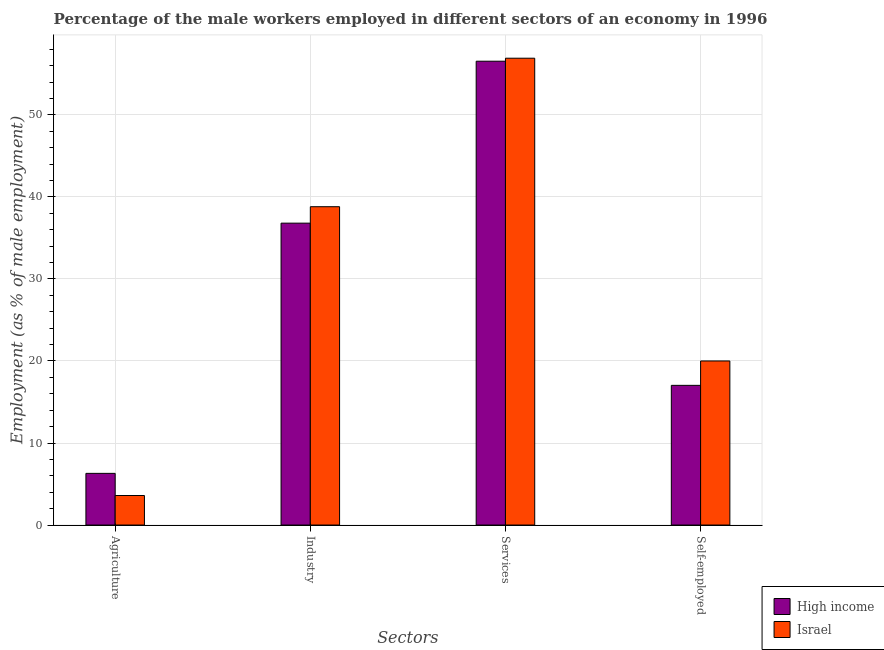How many different coloured bars are there?
Provide a short and direct response. 2. How many groups of bars are there?
Keep it short and to the point. 4. Are the number of bars on each tick of the X-axis equal?
Give a very brief answer. Yes. What is the label of the 4th group of bars from the left?
Ensure brevity in your answer.  Self-employed. What is the percentage of male workers in industry in Israel?
Make the answer very short. 38.8. Across all countries, what is the maximum percentage of male workers in industry?
Offer a terse response. 38.8. Across all countries, what is the minimum percentage of male workers in services?
Make the answer very short. 56.54. In which country was the percentage of male workers in industry minimum?
Keep it short and to the point. High income. What is the total percentage of self employed male workers in the graph?
Offer a very short reply. 37.03. What is the difference between the percentage of male workers in industry in Israel and that in High income?
Your answer should be compact. 2. What is the difference between the percentage of male workers in industry in High income and the percentage of male workers in services in Israel?
Your answer should be very brief. -20.1. What is the average percentage of male workers in agriculture per country?
Ensure brevity in your answer.  4.95. What is the difference between the percentage of male workers in agriculture and percentage of male workers in services in High income?
Offer a very short reply. -50.24. What is the ratio of the percentage of male workers in industry in High income to that in Israel?
Provide a succinct answer. 0.95. What is the difference between the highest and the second highest percentage of male workers in industry?
Provide a succinct answer. 2. What is the difference between the highest and the lowest percentage of male workers in services?
Your response must be concise. 0.36. Is it the case that in every country, the sum of the percentage of male workers in industry and percentage of male workers in services is greater than the sum of percentage of male workers in agriculture and percentage of self employed male workers?
Provide a succinct answer. Yes. What does the 2nd bar from the left in Agriculture represents?
Your response must be concise. Israel. What does the 1st bar from the right in Agriculture represents?
Give a very brief answer. Israel. Is it the case that in every country, the sum of the percentage of male workers in agriculture and percentage of male workers in industry is greater than the percentage of male workers in services?
Offer a terse response. No. How many bars are there?
Provide a succinct answer. 8. Are the values on the major ticks of Y-axis written in scientific E-notation?
Your answer should be compact. No. Does the graph contain grids?
Your response must be concise. Yes. How many legend labels are there?
Offer a terse response. 2. What is the title of the graph?
Offer a terse response. Percentage of the male workers employed in different sectors of an economy in 1996. What is the label or title of the X-axis?
Your response must be concise. Sectors. What is the label or title of the Y-axis?
Your answer should be very brief. Employment (as % of male employment). What is the Employment (as % of male employment) of High income in Agriculture?
Keep it short and to the point. 6.3. What is the Employment (as % of male employment) of Israel in Agriculture?
Make the answer very short. 3.6. What is the Employment (as % of male employment) in High income in Industry?
Your response must be concise. 36.8. What is the Employment (as % of male employment) of Israel in Industry?
Give a very brief answer. 38.8. What is the Employment (as % of male employment) of High income in Services?
Make the answer very short. 56.54. What is the Employment (as % of male employment) of Israel in Services?
Offer a very short reply. 56.9. What is the Employment (as % of male employment) in High income in Self-employed?
Offer a very short reply. 17.03. What is the Employment (as % of male employment) of Israel in Self-employed?
Provide a succinct answer. 20. Across all Sectors, what is the maximum Employment (as % of male employment) in High income?
Offer a very short reply. 56.54. Across all Sectors, what is the maximum Employment (as % of male employment) of Israel?
Give a very brief answer. 56.9. Across all Sectors, what is the minimum Employment (as % of male employment) of High income?
Offer a terse response. 6.3. Across all Sectors, what is the minimum Employment (as % of male employment) in Israel?
Offer a terse response. 3.6. What is the total Employment (as % of male employment) of High income in the graph?
Provide a short and direct response. 116.66. What is the total Employment (as % of male employment) of Israel in the graph?
Your response must be concise. 119.3. What is the difference between the Employment (as % of male employment) of High income in Agriculture and that in Industry?
Provide a short and direct response. -30.5. What is the difference between the Employment (as % of male employment) in Israel in Agriculture and that in Industry?
Ensure brevity in your answer.  -35.2. What is the difference between the Employment (as % of male employment) in High income in Agriculture and that in Services?
Make the answer very short. -50.24. What is the difference between the Employment (as % of male employment) of Israel in Agriculture and that in Services?
Your answer should be very brief. -53.3. What is the difference between the Employment (as % of male employment) in High income in Agriculture and that in Self-employed?
Give a very brief answer. -10.73. What is the difference between the Employment (as % of male employment) of Israel in Agriculture and that in Self-employed?
Offer a very short reply. -16.4. What is the difference between the Employment (as % of male employment) in High income in Industry and that in Services?
Provide a short and direct response. -19.74. What is the difference between the Employment (as % of male employment) in Israel in Industry and that in Services?
Provide a short and direct response. -18.1. What is the difference between the Employment (as % of male employment) in High income in Industry and that in Self-employed?
Your answer should be very brief. 19.77. What is the difference between the Employment (as % of male employment) of High income in Services and that in Self-employed?
Offer a terse response. 39.51. What is the difference between the Employment (as % of male employment) of Israel in Services and that in Self-employed?
Ensure brevity in your answer.  36.9. What is the difference between the Employment (as % of male employment) in High income in Agriculture and the Employment (as % of male employment) in Israel in Industry?
Offer a terse response. -32.5. What is the difference between the Employment (as % of male employment) in High income in Agriculture and the Employment (as % of male employment) in Israel in Services?
Provide a succinct answer. -50.6. What is the difference between the Employment (as % of male employment) in High income in Agriculture and the Employment (as % of male employment) in Israel in Self-employed?
Ensure brevity in your answer.  -13.7. What is the difference between the Employment (as % of male employment) of High income in Industry and the Employment (as % of male employment) of Israel in Services?
Offer a very short reply. -20.1. What is the difference between the Employment (as % of male employment) in High income in Industry and the Employment (as % of male employment) in Israel in Self-employed?
Offer a very short reply. 16.8. What is the difference between the Employment (as % of male employment) in High income in Services and the Employment (as % of male employment) in Israel in Self-employed?
Your answer should be compact. 36.54. What is the average Employment (as % of male employment) in High income per Sectors?
Keep it short and to the point. 29.16. What is the average Employment (as % of male employment) in Israel per Sectors?
Offer a terse response. 29.82. What is the difference between the Employment (as % of male employment) of High income and Employment (as % of male employment) of Israel in Agriculture?
Offer a terse response. 2.7. What is the difference between the Employment (as % of male employment) of High income and Employment (as % of male employment) of Israel in Industry?
Offer a very short reply. -2. What is the difference between the Employment (as % of male employment) of High income and Employment (as % of male employment) of Israel in Services?
Provide a succinct answer. -0.36. What is the difference between the Employment (as % of male employment) in High income and Employment (as % of male employment) in Israel in Self-employed?
Provide a succinct answer. -2.97. What is the ratio of the Employment (as % of male employment) of High income in Agriculture to that in Industry?
Provide a short and direct response. 0.17. What is the ratio of the Employment (as % of male employment) of Israel in Agriculture to that in Industry?
Your answer should be compact. 0.09. What is the ratio of the Employment (as % of male employment) in High income in Agriculture to that in Services?
Offer a terse response. 0.11. What is the ratio of the Employment (as % of male employment) in Israel in Agriculture to that in Services?
Make the answer very short. 0.06. What is the ratio of the Employment (as % of male employment) of High income in Agriculture to that in Self-employed?
Ensure brevity in your answer.  0.37. What is the ratio of the Employment (as % of male employment) of Israel in Agriculture to that in Self-employed?
Provide a succinct answer. 0.18. What is the ratio of the Employment (as % of male employment) of High income in Industry to that in Services?
Keep it short and to the point. 0.65. What is the ratio of the Employment (as % of male employment) of Israel in Industry to that in Services?
Make the answer very short. 0.68. What is the ratio of the Employment (as % of male employment) of High income in Industry to that in Self-employed?
Offer a terse response. 2.16. What is the ratio of the Employment (as % of male employment) of Israel in Industry to that in Self-employed?
Give a very brief answer. 1.94. What is the ratio of the Employment (as % of male employment) of High income in Services to that in Self-employed?
Provide a succinct answer. 3.32. What is the ratio of the Employment (as % of male employment) of Israel in Services to that in Self-employed?
Provide a succinct answer. 2.85. What is the difference between the highest and the second highest Employment (as % of male employment) in High income?
Your answer should be compact. 19.74. What is the difference between the highest and the second highest Employment (as % of male employment) in Israel?
Your response must be concise. 18.1. What is the difference between the highest and the lowest Employment (as % of male employment) in High income?
Your response must be concise. 50.24. What is the difference between the highest and the lowest Employment (as % of male employment) in Israel?
Make the answer very short. 53.3. 